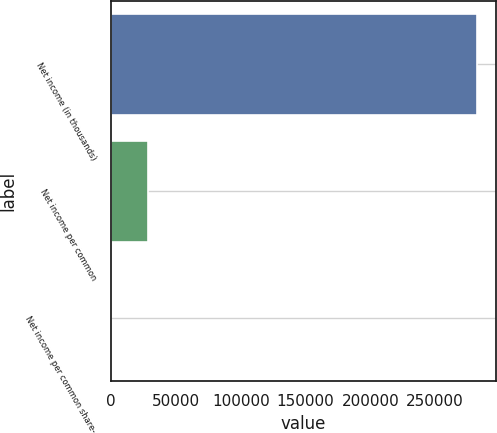Convert chart. <chart><loc_0><loc_0><loc_500><loc_500><bar_chart><fcel>Net income (in thousands)<fcel>Net income per common<fcel>Net income per common share-<nl><fcel>282460<fcel>28248.3<fcel>2.6<nl></chart> 